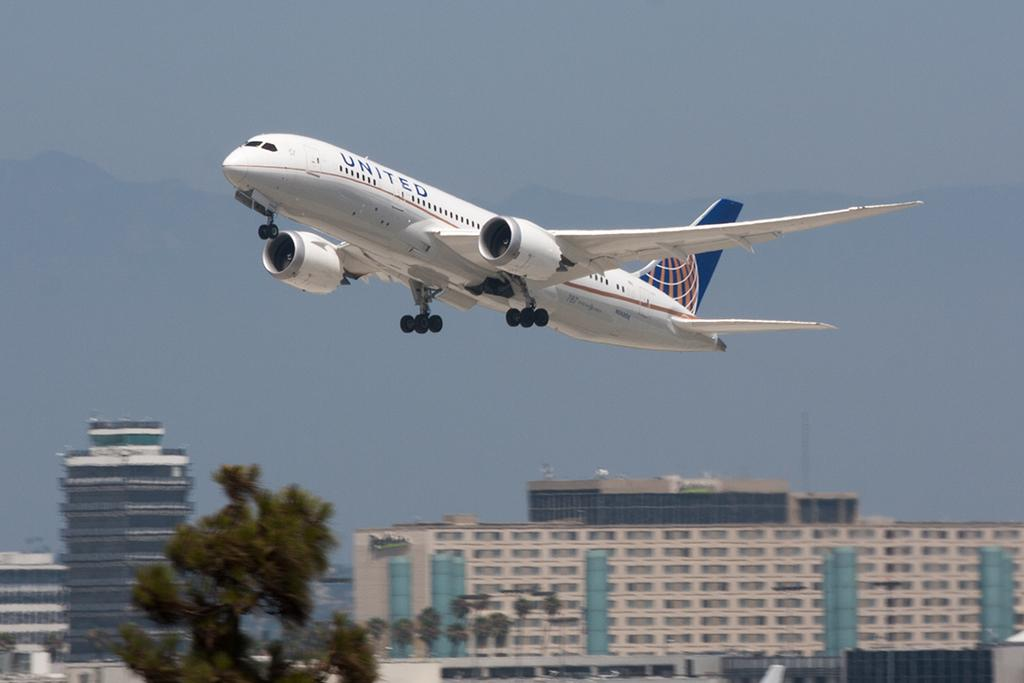Provide a one-sentence caption for the provided image. A United airplane is taking off into the sky. 